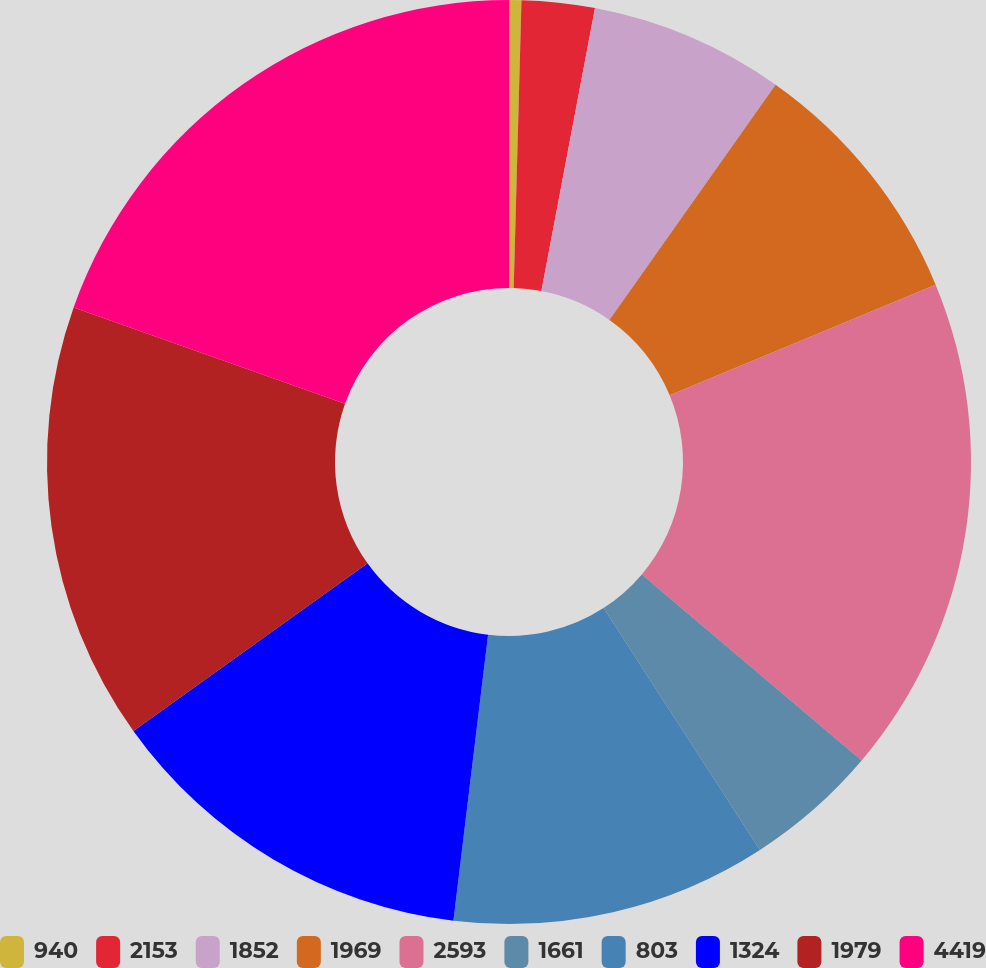Convert chart to OTSL. <chart><loc_0><loc_0><loc_500><loc_500><pie_chart><fcel>940<fcel>2153<fcel>1852<fcel>1969<fcel>2593<fcel>1661<fcel>803<fcel>1324<fcel>1979<fcel>4419<nl><fcel>0.43%<fcel>2.55%<fcel>6.81%<fcel>8.94%<fcel>17.45%<fcel>4.68%<fcel>11.06%<fcel>13.19%<fcel>15.32%<fcel>19.57%<nl></chart> 